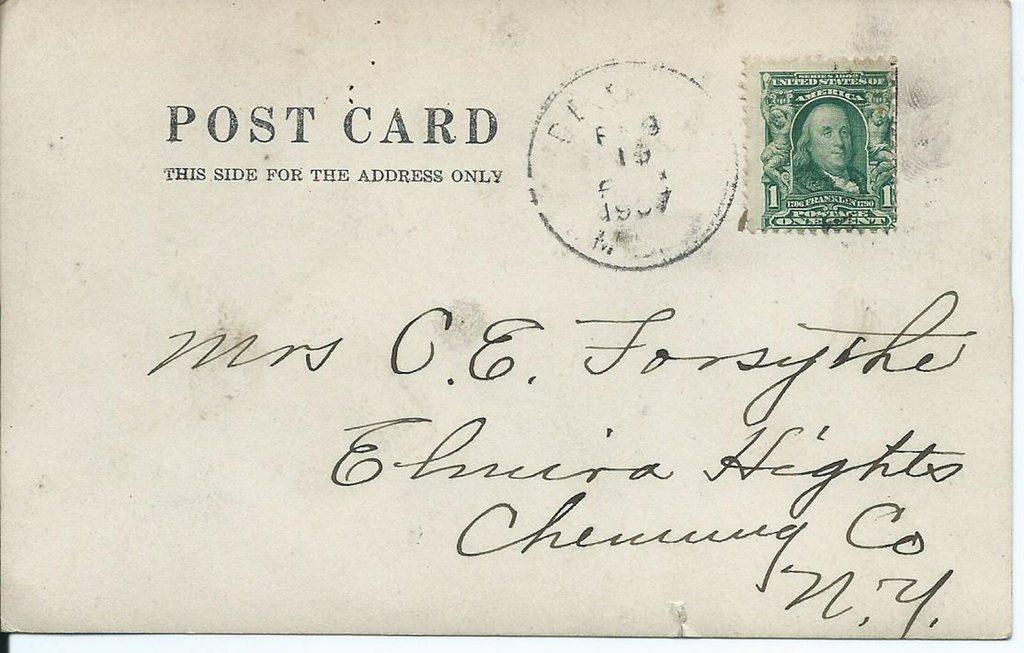Provide a one-sentence caption for the provided image. A post card with a dollar sign stamp has writing in cursive on it. 